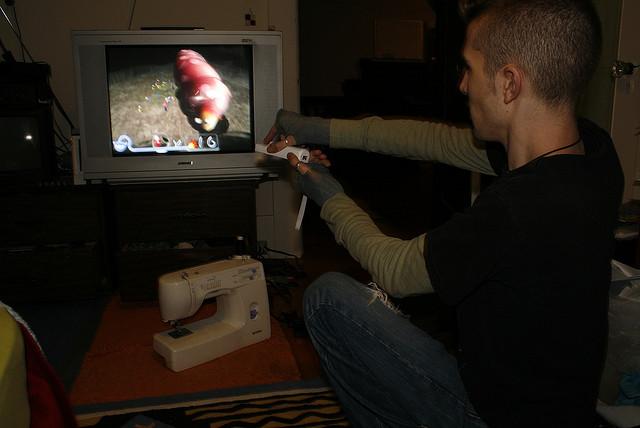What color shirt is the man wearing?
Be succinct. Black. Do you see a sewing machine?
Be succinct. Yes. What game platform is the man using?
Concise answer only. Wii. 